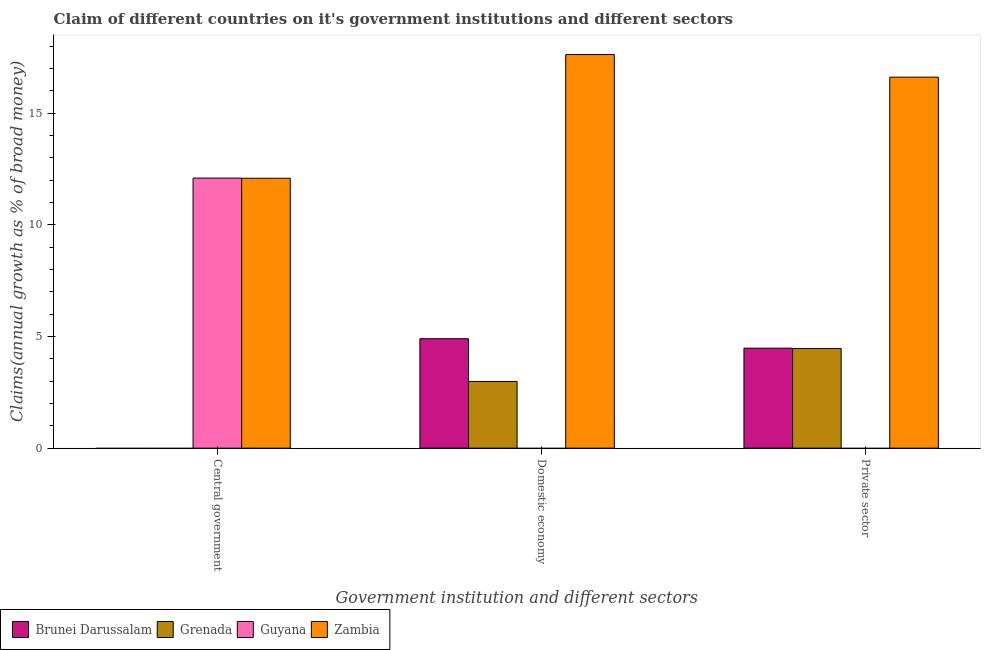How many groups of bars are there?
Your answer should be very brief. 3. Are the number of bars per tick equal to the number of legend labels?
Offer a terse response. No. How many bars are there on the 3rd tick from the left?
Ensure brevity in your answer.  3. How many bars are there on the 3rd tick from the right?
Make the answer very short. 2. What is the label of the 2nd group of bars from the left?
Ensure brevity in your answer.  Domestic economy. What is the percentage of claim on the private sector in Brunei Darussalam?
Your response must be concise. 4.48. Across all countries, what is the maximum percentage of claim on the private sector?
Give a very brief answer. 16.61. Across all countries, what is the minimum percentage of claim on the domestic economy?
Make the answer very short. 0. In which country was the percentage of claim on the domestic economy maximum?
Your response must be concise. Zambia. What is the total percentage of claim on the domestic economy in the graph?
Your answer should be compact. 25.51. What is the difference between the percentage of claim on the central government in Guyana and that in Zambia?
Offer a very short reply. 0.01. What is the difference between the percentage of claim on the central government in Guyana and the percentage of claim on the domestic economy in Grenada?
Your response must be concise. 9.11. What is the average percentage of claim on the central government per country?
Make the answer very short. 6.04. What is the difference between the percentage of claim on the private sector and percentage of claim on the domestic economy in Grenada?
Your answer should be compact. 1.48. What is the ratio of the percentage of claim on the central government in Zambia to that in Guyana?
Offer a very short reply. 1. Is the percentage of claim on the private sector in Grenada less than that in Brunei Darussalam?
Offer a terse response. Yes. What is the difference between the highest and the second highest percentage of claim on the domestic economy?
Keep it short and to the point. 12.72. What is the difference between the highest and the lowest percentage of claim on the central government?
Offer a terse response. 12.09. In how many countries, is the percentage of claim on the domestic economy greater than the average percentage of claim on the domestic economy taken over all countries?
Your answer should be very brief. 1. Is it the case that in every country, the sum of the percentage of claim on the central government and percentage of claim on the domestic economy is greater than the percentage of claim on the private sector?
Offer a very short reply. No. How many countries are there in the graph?
Keep it short and to the point. 4. Does the graph contain any zero values?
Provide a short and direct response. Yes. Does the graph contain grids?
Provide a short and direct response. No. How are the legend labels stacked?
Your answer should be compact. Horizontal. What is the title of the graph?
Offer a terse response. Claim of different countries on it's government institutions and different sectors. What is the label or title of the X-axis?
Your response must be concise. Government institution and different sectors. What is the label or title of the Y-axis?
Ensure brevity in your answer.  Claims(annual growth as % of broad money). What is the Claims(annual growth as % of broad money) of Guyana in Central government?
Your answer should be very brief. 12.09. What is the Claims(annual growth as % of broad money) of Zambia in Central government?
Give a very brief answer. 12.08. What is the Claims(annual growth as % of broad money) in Brunei Darussalam in Domestic economy?
Your answer should be compact. 4.9. What is the Claims(annual growth as % of broad money) in Grenada in Domestic economy?
Offer a terse response. 2.99. What is the Claims(annual growth as % of broad money) in Zambia in Domestic economy?
Provide a succinct answer. 17.62. What is the Claims(annual growth as % of broad money) of Brunei Darussalam in Private sector?
Keep it short and to the point. 4.48. What is the Claims(annual growth as % of broad money) in Grenada in Private sector?
Make the answer very short. 4.46. What is the Claims(annual growth as % of broad money) in Zambia in Private sector?
Ensure brevity in your answer.  16.61. Across all Government institution and different sectors, what is the maximum Claims(annual growth as % of broad money) in Brunei Darussalam?
Your answer should be compact. 4.9. Across all Government institution and different sectors, what is the maximum Claims(annual growth as % of broad money) of Grenada?
Provide a short and direct response. 4.46. Across all Government institution and different sectors, what is the maximum Claims(annual growth as % of broad money) in Guyana?
Make the answer very short. 12.09. Across all Government institution and different sectors, what is the maximum Claims(annual growth as % of broad money) of Zambia?
Ensure brevity in your answer.  17.62. Across all Government institution and different sectors, what is the minimum Claims(annual growth as % of broad money) of Guyana?
Provide a short and direct response. 0. Across all Government institution and different sectors, what is the minimum Claims(annual growth as % of broad money) in Zambia?
Offer a terse response. 12.08. What is the total Claims(annual growth as % of broad money) in Brunei Darussalam in the graph?
Give a very brief answer. 9.38. What is the total Claims(annual growth as % of broad money) in Grenada in the graph?
Make the answer very short. 7.45. What is the total Claims(annual growth as % of broad money) in Guyana in the graph?
Your response must be concise. 12.09. What is the total Claims(annual growth as % of broad money) in Zambia in the graph?
Your response must be concise. 46.32. What is the difference between the Claims(annual growth as % of broad money) of Zambia in Central government and that in Domestic economy?
Provide a succinct answer. -5.54. What is the difference between the Claims(annual growth as % of broad money) in Zambia in Central government and that in Private sector?
Keep it short and to the point. -4.53. What is the difference between the Claims(annual growth as % of broad money) of Brunei Darussalam in Domestic economy and that in Private sector?
Provide a short and direct response. 0.42. What is the difference between the Claims(annual growth as % of broad money) in Grenada in Domestic economy and that in Private sector?
Your answer should be compact. -1.48. What is the difference between the Claims(annual growth as % of broad money) of Zambia in Domestic economy and that in Private sector?
Make the answer very short. 1.01. What is the difference between the Claims(annual growth as % of broad money) in Guyana in Central government and the Claims(annual growth as % of broad money) in Zambia in Domestic economy?
Keep it short and to the point. -5.53. What is the difference between the Claims(annual growth as % of broad money) of Guyana in Central government and the Claims(annual growth as % of broad money) of Zambia in Private sector?
Provide a succinct answer. -4.52. What is the difference between the Claims(annual growth as % of broad money) in Brunei Darussalam in Domestic economy and the Claims(annual growth as % of broad money) in Grenada in Private sector?
Your answer should be compact. 0.44. What is the difference between the Claims(annual growth as % of broad money) of Brunei Darussalam in Domestic economy and the Claims(annual growth as % of broad money) of Zambia in Private sector?
Provide a succinct answer. -11.71. What is the difference between the Claims(annual growth as % of broad money) of Grenada in Domestic economy and the Claims(annual growth as % of broad money) of Zambia in Private sector?
Ensure brevity in your answer.  -13.62. What is the average Claims(annual growth as % of broad money) of Brunei Darussalam per Government institution and different sectors?
Give a very brief answer. 3.13. What is the average Claims(annual growth as % of broad money) of Grenada per Government institution and different sectors?
Your answer should be very brief. 2.48. What is the average Claims(annual growth as % of broad money) in Guyana per Government institution and different sectors?
Your answer should be very brief. 4.03. What is the average Claims(annual growth as % of broad money) in Zambia per Government institution and different sectors?
Provide a succinct answer. 15.44. What is the difference between the Claims(annual growth as % of broad money) of Guyana and Claims(annual growth as % of broad money) of Zambia in Central government?
Provide a short and direct response. 0.01. What is the difference between the Claims(annual growth as % of broad money) of Brunei Darussalam and Claims(annual growth as % of broad money) of Grenada in Domestic economy?
Provide a succinct answer. 1.91. What is the difference between the Claims(annual growth as % of broad money) of Brunei Darussalam and Claims(annual growth as % of broad money) of Zambia in Domestic economy?
Ensure brevity in your answer.  -12.72. What is the difference between the Claims(annual growth as % of broad money) in Grenada and Claims(annual growth as % of broad money) in Zambia in Domestic economy?
Your response must be concise. -14.64. What is the difference between the Claims(annual growth as % of broad money) in Brunei Darussalam and Claims(annual growth as % of broad money) in Grenada in Private sector?
Your answer should be compact. 0.01. What is the difference between the Claims(annual growth as % of broad money) in Brunei Darussalam and Claims(annual growth as % of broad money) in Zambia in Private sector?
Make the answer very short. -12.13. What is the difference between the Claims(annual growth as % of broad money) of Grenada and Claims(annual growth as % of broad money) of Zambia in Private sector?
Make the answer very short. -12.15. What is the ratio of the Claims(annual growth as % of broad money) of Zambia in Central government to that in Domestic economy?
Provide a succinct answer. 0.69. What is the ratio of the Claims(annual growth as % of broad money) in Zambia in Central government to that in Private sector?
Ensure brevity in your answer.  0.73. What is the ratio of the Claims(annual growth as % of broad money) in Brunei Darussalam in Domestic economy to that in Private sector?
Ensure brevity in your answer.  1.09. What is the ratio of the Claims(annual growth as % of broad money) in Grenada in Domestic economy to that in Private sector?
Provide a succinct answer. 0.67. What is the ratio of the Claims(annual growth as % of broad money) of Zambia in Domestic economy to that in Private sector?
Offer a terse response. 1.06. What is the difference between the highest and the second highest Claims(annual growth as % of broad money) in Zambia?
Provide a short and direct response. 1.01. What is the difference between the highest and the lowest Claims(annual growth as % of broad money) in Brunei Darussalam?
Your answer should be very brief. 4.9. What is the difference between the highest and the lowest Claims(annual growth as % of broad money) of Grenada?
Ensure brevity in your answer.  4.46. What is the difference between the highest and the lowest Claims(annual growth as % of broad money) of Guyana?
Offer a terse response. 12.09. What is the difference between the highest and the lowest Claims(annual growth as % of broad money) in Zambia?
Make the answer very short. 5.54. 